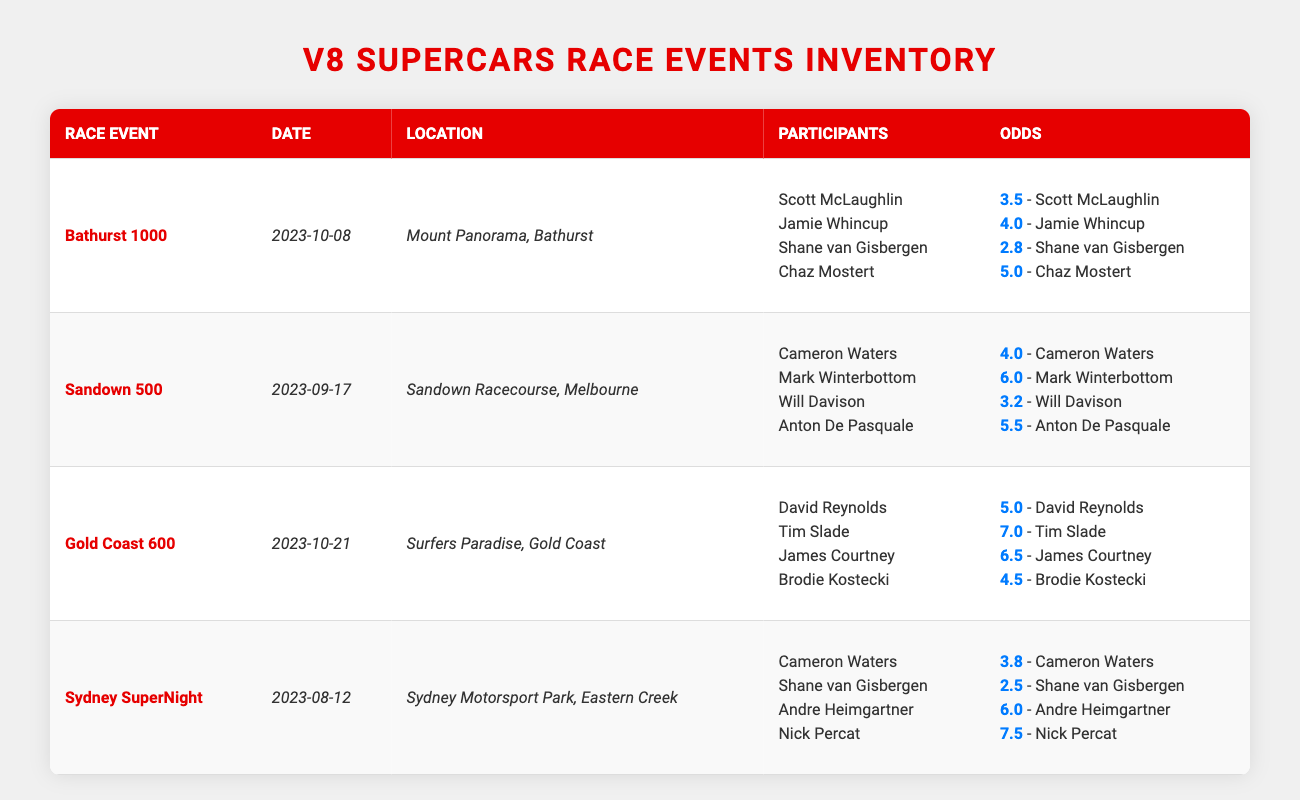What is the date of the Bathurst 1000 race event? The table lists the Bathurst 1000 event, and the date associated with it is mentioned as 2023-10-08.
Answer: 2023-10-08 Which participant has the lowest odds in the Gold Coast 600? In the Gold Coast 600 section, the odds for each participant are provided. David Reynolds has odds of 5.0, Tim Slade has 7.0, James Courtney has 6.5, and Brodie Kostecki has 4.5, making Brodie Kostecki the participant with the lowest odds.
Answer: Brodie Kostecki True or False: The Sandown 500 race is held at Mount Panorama, Bathurst. The location listed for the Sandown 500 race is Sandown Racecourse, Melbourne, while Mount Panorama, Bathurst is the location for the Bathurst 1000 race, hence this statement is false.
Answer: False What is the difference in odds between Shane van Gisbergen and Jamie Whincup in the Bathurst 1000? In the Bathurst 1000, Shane van Gisbergen has odds of 2.8 and Jamie Whincup has odds of 4.0. The difference is calculated as 4.0 - 2.8 = 1.2.
Answer: 1.2 Which event has the latest date among the listed races? Examining the dates, Bathurst 1000 is on 2023-10-08, Sandown 500 is on 2023-09-17, Gold Coast 600 is on 2023-10-21, and Sydney SuperNight is on 2023-08-12. The latest date is 2023-10-21 for the Gold Coast 600.
Answer: Gold Coast 600 What is the total number of participants listed for each of the events combined? Each of the events has 4 participants, and there are 4 events listed (Bathurst 1000, Sandown 500, Gold Coast 600, and Sydney SuperNight). Thus, total participants are 4 * 4 = 16.
Answer: 16 True or False: Cameron Waters has better odds in the Sydney SuperNight compared to the Sandown 500. Cameron Waters has odds of 3.8 in the Sydney SuperNight and 4.0 in the Sandown 500. Since 3.8 is lower than 4.0, he has better odds in the Sydney SuperNight, making the statement true.
Answer: True What are the combined odds of the four participants in the Sydney SuperNight? The odds for the participants in the Sydney SuperNight are 3.8 (Cameron Waters), 2.5 (Shane van Gisbergen), 6.0 (Andre Heimgartner), and 7.5 (Nick Percat). Summing these gives 3.8 + 2.5 + 6.0 + 7.5 = 19.8.
Answer: 19.8 Which participant appears in both the Sydney SuperNight and Bathurst 1000 events? From the participants list for both events, Cameron Waters is in the Sydney SuperNight and also appears in the participants for Bathurst 1000.
Answer: Cameron Waters 